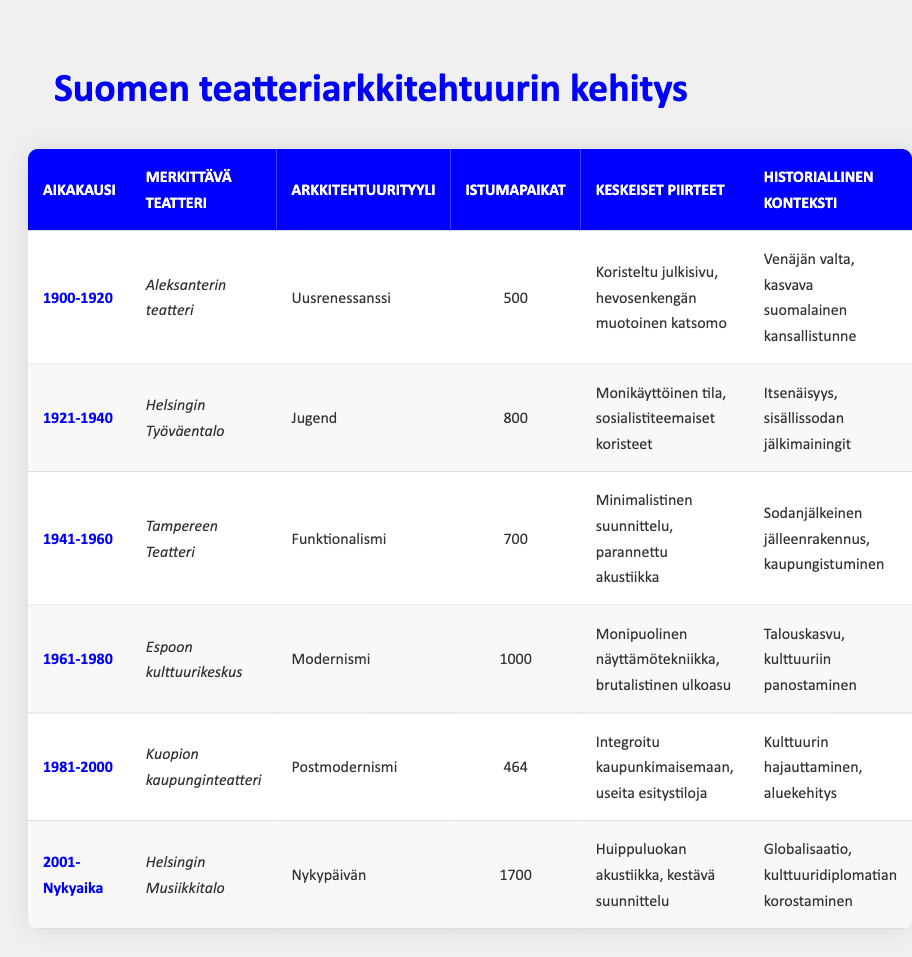What architectural style is used in the Helsinki Workers' House? According to the table, the Helsinki Workers' House, which represents the era from 1921 to 1940, is designed in the Art Nouveau style.
Answer: Art Nouveau Which theater has the largest seating capacity and what is that capacity? The Helsinki Music Centre, built from 2001 to the present, has the largest seating capacity listed in the table, which is 1700.
Answer: 1700 Is the Alexander Theatre a functionalist style theater? The table indicates that the Alexander Theatre is designed in the Neo-Renaissance style, not functionalism, which was used in Tampere Theatre. Therefore, the statement is false.
Answer: No How many more seats does the Espoo Cultural Centre have compared to Kuopio City Theatre? The Espoo Cultural Centre has a seating capacity of 1000 and Kuopio City Theatre has 464. The difference is calculated as 1000 - 464 = 536.
Answer: 536 What key features are common between the Tampere Theatre and the Helsinki Music Centre? From the table, Tampere Theatre features minimalist design and improved acoustics, while Helsinki Music Centre offers state-of-the-art acoustics. The common feature is improved acoustics, but their design styles are different.
Answer: Improved acoustics What is the average seating capacity of theaters from the era 1941 to 2000? The seating capacities of those theaters are 700 (Tampere Theatre), 1000 (Espoo Cultural Centre), and 464 (Kuopio City Theatre). Adding these gives 700 + 1000 + 464 = 2164. We divide by the number of theaters, which is 3, resulting in an average of 2164 / 3 = 721.33.
Answer: 721.33 Did the expansion of cultural investments in Finland during the 1961-1980 era influence theatre architecture? The table specifically notes that the Espoo Cultural Centre, built during this era, reflects economic growth and investments in culture, suggesting that this led to modernist architectural styles being adopted. Thus, the answer is yes.
Answer: Yes What were the key features of the Kuopio City Theatre? The table lists the key features of Kuopio City Theatre as the integration with the urban landscape and having multiple performance spaces.
Answer: Integration with urban landscape, multiple performance spaces 